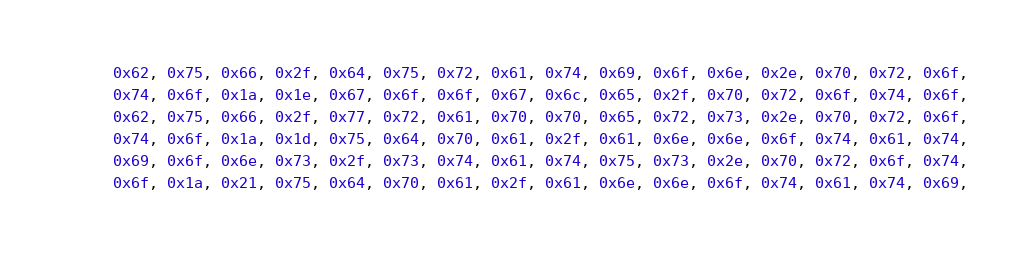<code> <loc_0><loc_0><loc_500><loc_500><_Go_>	0x62, 0x75, 0x66, 0x2f, 0x64, 0x75, 0x72, 0x61, 0x74, 0x69, 0x6f, 0x6e, 0x2e, 0x70, 0x72, 0x6f,
	0x74, 0x6f, 0x1a, 0x1e, 0x67, 0x6f, 0x6f, 0x67, 0x6c, 0x65, 0x2f, 0x70, 0x72, 0x6f, 0x74, 0x6f,
	0x62, 0x75, 0x66, 0x2f, 0x77, 0x72, 0x61, 0x70, 0x70, 0x65, 0x72, 0x73, 0x2e, 0x70, 0x72, 0x6f,
	0x74, 0x6f, 0x1a, 0x1d, 0x75, 0x64, 0x70, 0x61, 0x2f, 0x61, 0x6e, 0x6e, 0x6f, 0x74, 0x61, 0x74,
	0x69, 0x6f, 0x6e, 0x73, 0x2f, 0x73, 0x74, 0x61, 0x74, 0x75, 0x73, 0x2e, 0x70, 0x72, 0x6f, 0x74,
	0x6f, 0x1a, 0x21, 0x75, 0x64, 0x70, 0x61, 0x2f, 0x61, 0x6e, 0x6e, 0x6f, 0x74, 0x61, 0x74, 0x69,</code> 